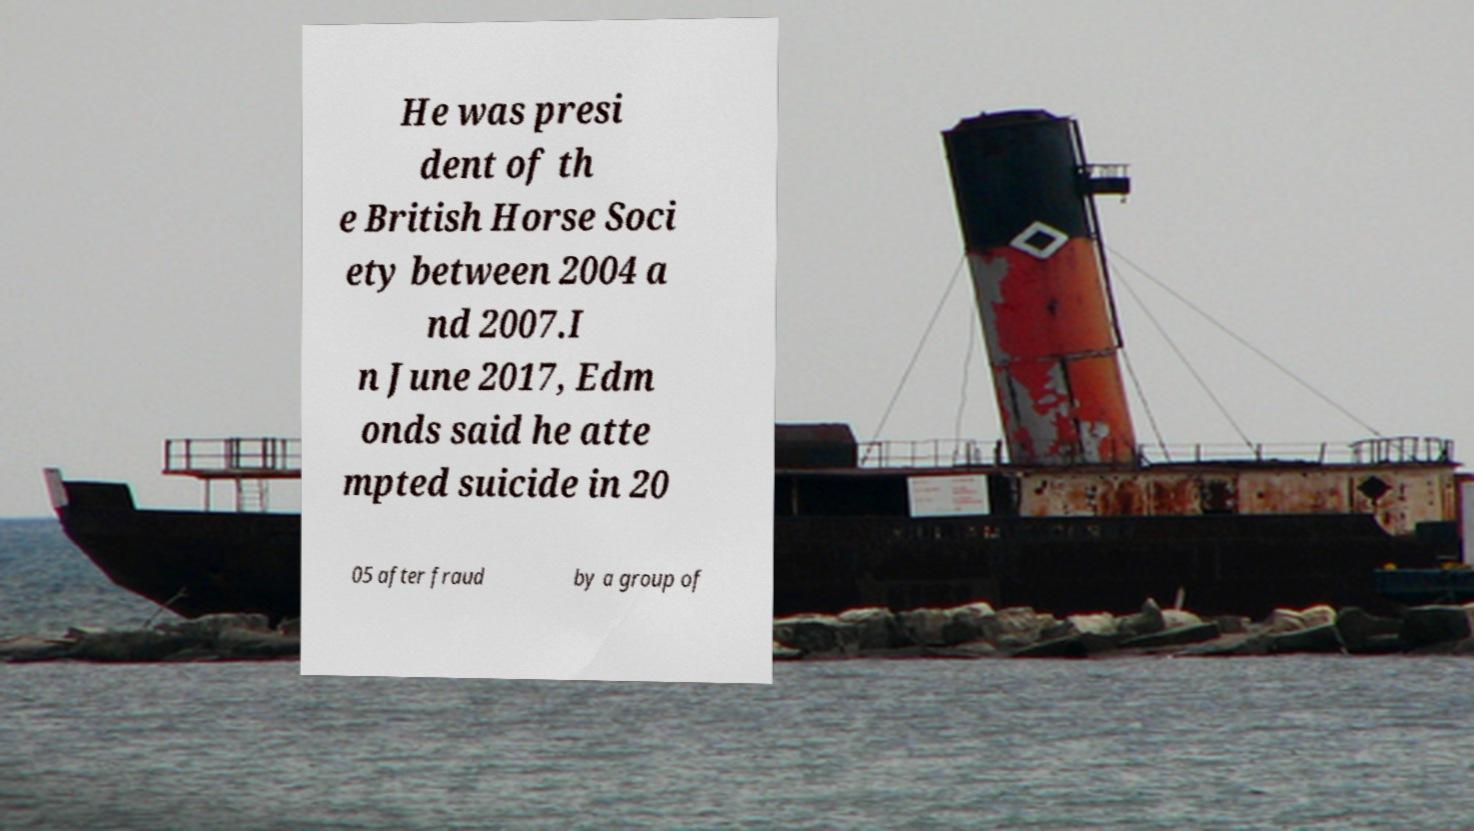What messages or text are displayed in this image? I need them in a readable, typed format. He was presi dent of th e British Horse Soci ety between 2004 a nd 2007.I n June 2017, Edm onds said he atte mpted suicide in 20 05 after fraud by a group of 